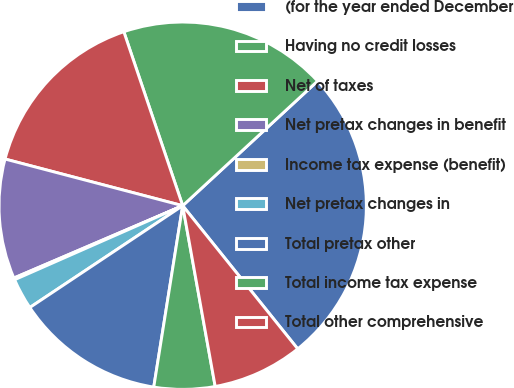Convert chart to OTSL. <chart><loc_0><loc_0><loc_500><loc_500><pie_chart><fcel>(for the year ended December<fcel>Having no credit losses<fcel>Net of taxes<fcel>Net pretax changes in benefit<fcel>Income tax expense (benefit)<fcel>Net pretax changes in<fcel>Total pretax other<fcel>Total income tax expense<fcel>Total other comprehensive<nl><fcel>26.1%<fcel>18.32%<fcel>15.72%<fcel>10.53%<fcel>0.16%<fcel>2.75%<fcel>13.13%<fcel>5.35%<fcel>7.94%<nl></chart> 